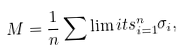Convert formula to latex. <formula><loc_0><loc_0><loc_500><loc_500>M = \frac { 1 } { n } \sum \lim i t s _ { i = 1 } ^ { n } { \sigma _ { i } } ,</formula> 